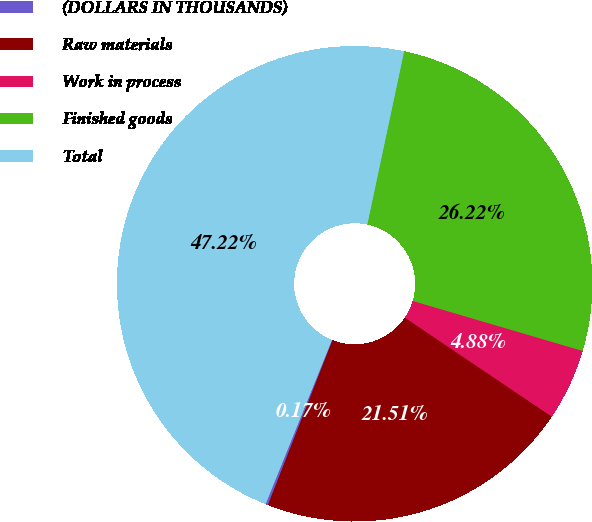<chart> <loc_0><loc_0><loc_500><loc_500><pie_chart><fcel>(DOLLARS IN THOUSANDS)<fcel>Raw materials<fcel>Work in process<fcel>Finished goods<fcel>Total<nl><fcel>0.17%<fcel>21.51%<fcel>4.88%<fcel>26.22%<fcel>47.22%<nl></chart> 